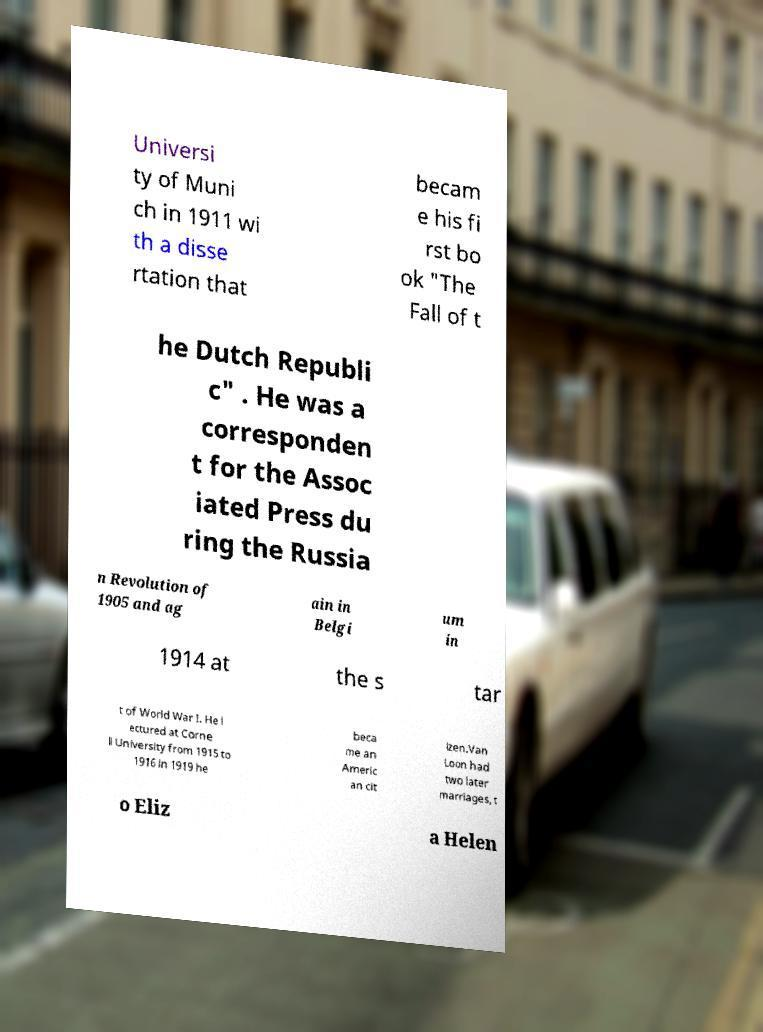Please read and relay the text visible in this image. What does it say? Universi ty of Muni ch in 1911 wi th a disse rtation that becam e his fi rst bo ok "The Fall of t he Dutch Republi c" . He was a corresponden t for the Assoc iated Press du ring the Russia n Revolution of 1905 and ag ain in Belgi um in 1914 at the s tar t of World War I. He l ectured at Corne ll University from 1915 to 1916 in 1919 he beca me an Americ an cit izen.Van Loon had two later marriages, t o Eliz a Helen 